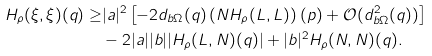<formula> <loc_0><loc_0><loc_500><loc_500>H _ { \rho } ( \xi , \xi ) ( q ) \geq & | a | ^ { 2 } \left [ - 2 d _ { b \Omega } ( q ) \left ( N H _ { \rho } ( L , L ) \right ) ( p ) + \mathcal { O } ( d ^ { 2 } _ { b \Omega } ( q ) ) \right ] \\ & - 2 | a | | b | | H _ { \rho } ( L , N ) ( q ) | + | b | ^ { 2 } H _ { \rho } ( N , N ) ( q ) .</formula> 